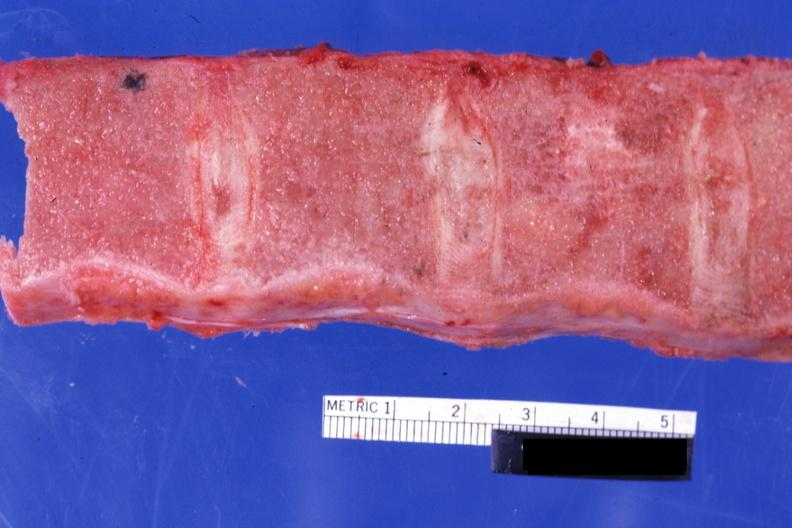how does this image show sectioned vertebrae?
Answer the question using a single word or phrase. With no red marrow case of chronic myelogenous leukemia in blast crisis 